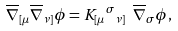Convert formula to latex. <formula><loc_0><loc_0><loc_500><loc_500>\overline { \nabla } _ { [ \mu } \overline { \nabla } _ { \nu ] } \phi = K _ { [ \mu } { ^ { \sigma } } _ { \nu ] } \ \overline { \nabla } _ { \sigma } \phi ,</formula> 